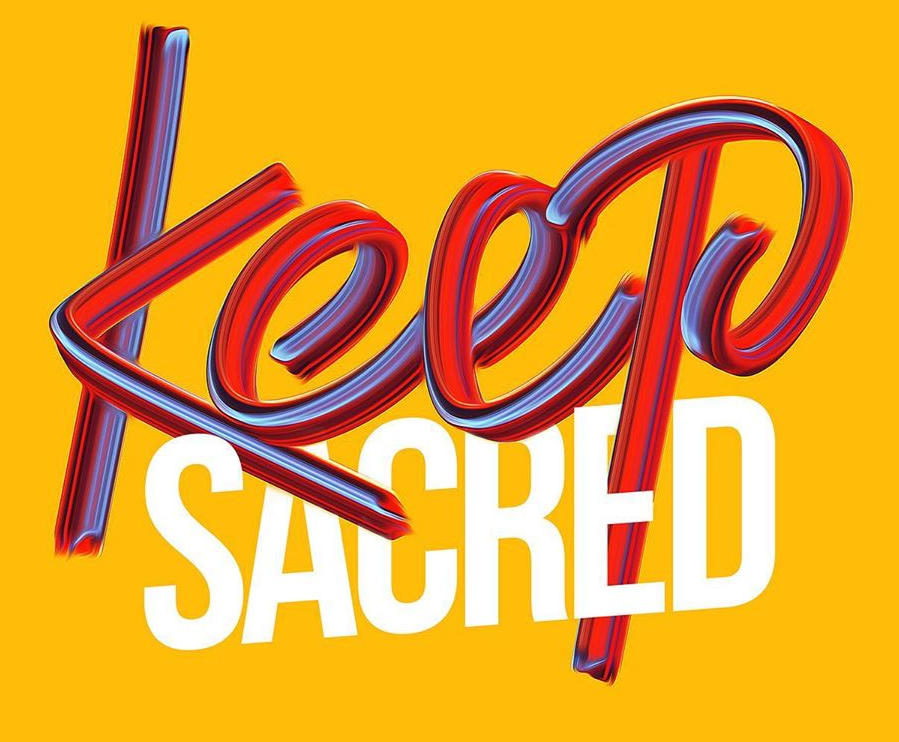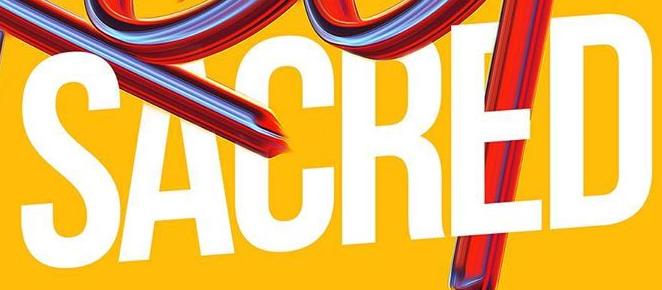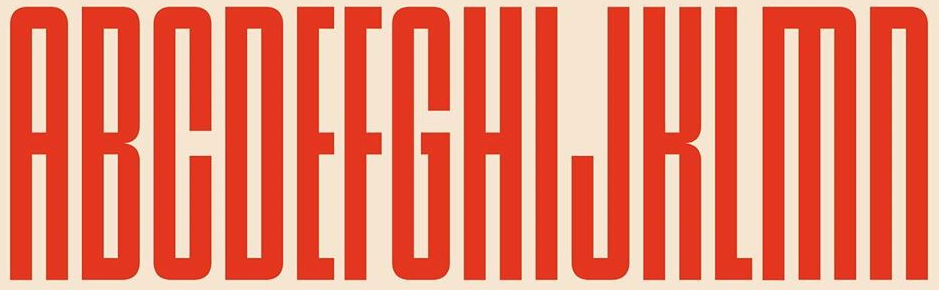What words are shown in these images in order, separated by a semicolon? Keep; SACRED; ABCDEFGHIJKLMN 